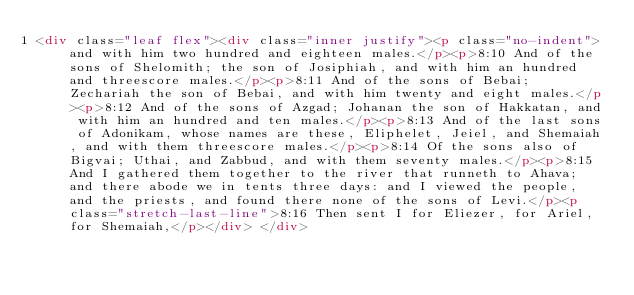Convert code to text. <code><loc_0><loc_0><loc_500><loc_500><_HTML_><div class="leaf flex"><div class="inner justify"><p class="no-indent">and with him two hundred and eighteen males.</p><p>8:10 And of the sons of Shelomith; the son of Josiphiah, and with him an hundred and threescore males.</p><p>8:11 And of the sons of Bebai; Zechariah the son of Bebai, and with him twenty and eight males.</p><p>8:12 And of the sons of Azgad; Johanan the son of Hakkatan, and with him an hundred and ten males.</p><p>8:13 And of the last sons of Adonikam, whose names are these, Eliphelet, Jeiel, and Shemaiah, and with them threescore males.</p><p>8:14 Of the sons also of Bigvai; Uthai, and Zabbud, and with them seventy males.</p><p>8:15 And I gathered them together to the river that runneth to Ahava; and there abode we in tents three days: and I viewed the people, and the priests, and found there none of the sons of Levi.</p><p class="stretch-last-line">8:16 Then sent I for Eliezer, for Ariel, for Shemaiah,</p></div> </div></code> 